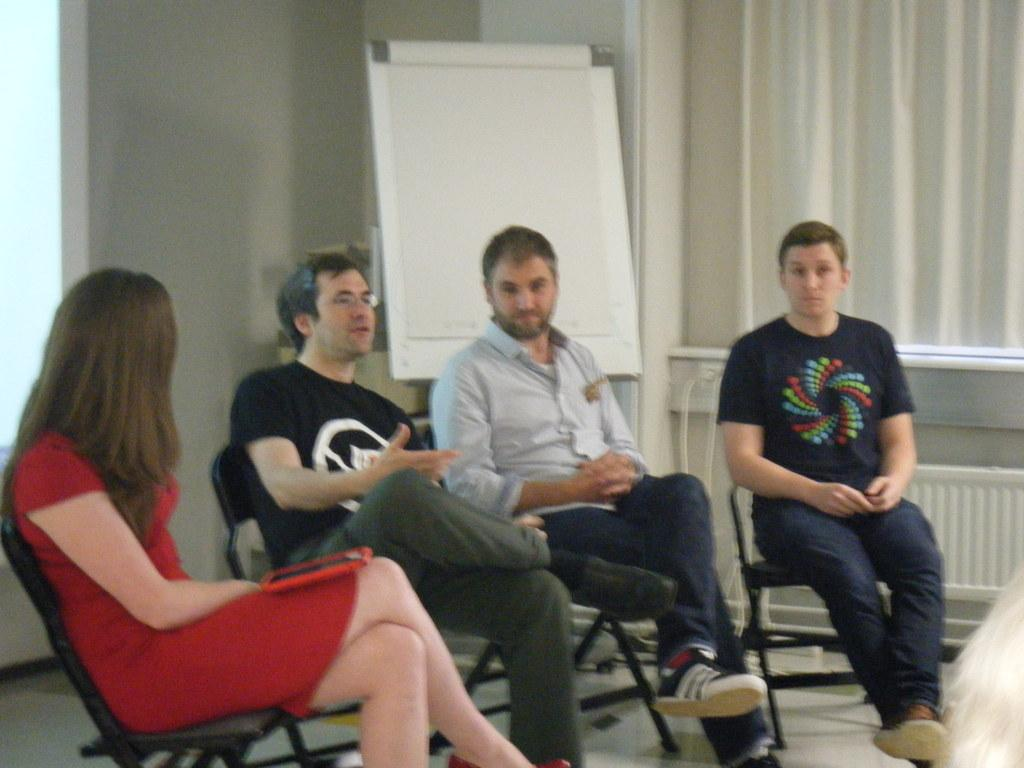How many people are sitting in the image? There are four people sitting on chairs in the image. What is located behind the people? There is a whiteboard behind the people. Can you describe any other elements in the image? There is a white curtain present at the right side of the image. What type of soup is being served to the people in the image? There is no soup present in the image. What color is the vest worn by the person on the left side of the image? There are no vests visible in the image. 